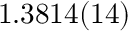<formula> <loc_0><loc_0><loc_500><loc_500>1 . 3 8 1 4 ( 1 4 )</formula> 